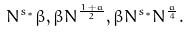Convert formula to latex. <formula><loc_0><loc_0><loc_500><loc_500>N ^ { s _ { * } } \beta , \beta N ^ { \frac { 1 + a } { 2 } } , \beta N ^ { s _ { * } } N ^ { \frac { a } { 4 } } .</formula> 